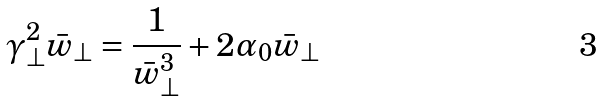<formula> <loc_0><loc_0><loc_500><loc_500>\gamma _ { \perp } ^ { 2 } \bar { w } _ { \perp } = \frac { 1 } { \bar { w } _ { \perp } ^ { 3 } } + 2 \alpha _ { 0 } \bar { w } _ { \perp }</formula> 